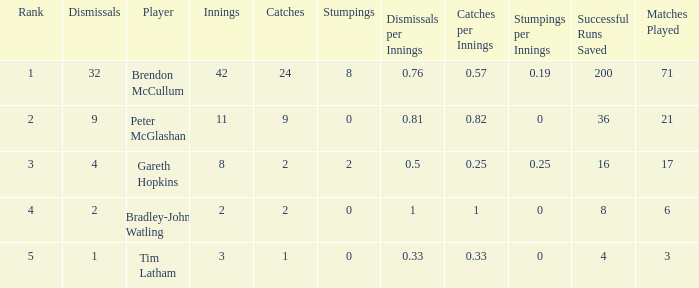How many dismissals did the player Peter McGlashan have? 9.0. Could you parse the entire table as a dict? {'header': ['Rank', 'Dismissals', 'Player', 'Innings', 'Catches', 'Stumpings', 'Dismissals per Innings', 'Catches per Innings', 'Stumpings per Innings', 'Successful Runs Saved', 'Matches Played'], 'rows': [['1', '32', 'Brendon McCullum', '42', '24', '8', '0.76', '0.57', '0.19', '200', '71'], ['2', '9', 'Peter McGlashan', '11', '9', '0', '0.81', '0.82', '0', '36', '21'], ['3', '4', 'Gareth Hopkins', '8', '2', '2', '0.5', '0.25', '0.25', '16', '17'], ['4', '2', 'Bradley-John Watling', '2', '2', '0', '1', '1', '0', '8', '6'], ['5', '1', 'Tim Latham', '3', '1', '0', '0.33', '0.33', '0', '4', '3']]} 